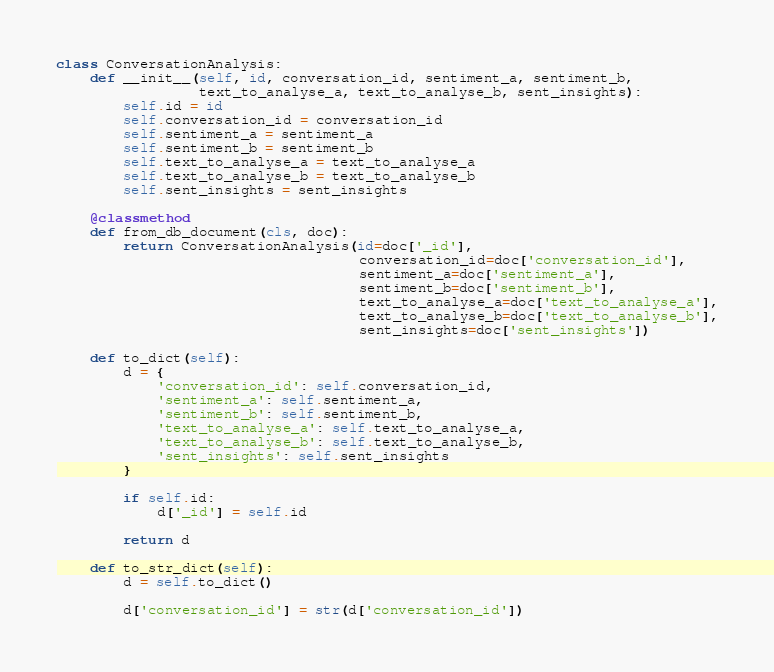Convert code to text. <code><loc_0><loc_0><loc_500><loc_500><_Python_>class ConversationAnalysis:
    def __init__(self, id, conversation_id, sentiment_a, sentiment_b,
                 text_to_analyse_a, text_to_analyse_b, sent_insights):
        self.id = id
        self.conversation_id = conversation_id
        self.sentiment_a = sentiment_a
        self.sentiment_b = sentiment_b
        self.text_to_analyse_a = text_to_analyse_a
        self.text_to_analyse_b = text_to_analyse_b
        self.sent_insights = sent_insights

    @classmethod
    def from_db_document(cls, doc):
        return ConversationAnalysis(id=doc['_id'],
                                    conversation_id=doc['conversation_id'],
                                    sentiment_a=doc['sentiment_a'],
                                    sentiment_b=doc['sentiment_b'],
                                    text_to_analyse_a=doc['text_to_analyse_a'],
                                    text_to_analyse_b=doc['text_to_analyse_b'],
                                    sent_insights=doc['sent_insights'])

    def to_dict(self):
        d = {
            'conversation_id': self.conversation_id,
            'sentiment_a': self.sentiment_a,
            'sentiment_b': self.sentiment_b,
            'text_to_analyse_a': self.text_to_analyse_a,
            'text_to_analyse_b': self.text_to_analyse_b,
            'sent_insights': self.sent_insights
        }

        if self.id:
            d['_id'] = self.id

        return d

    def to_str_dict(self):
        d = self.to_dict()

        d['conversation_id'] = str(d['conversation_id'])
</code> 